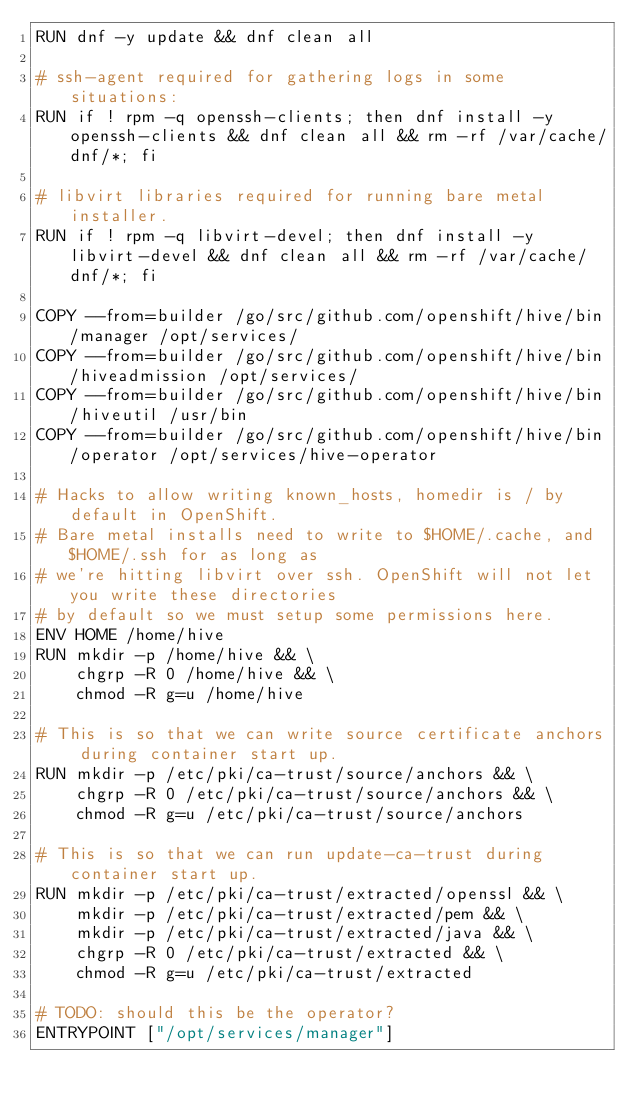Convert code to text. <code><loc_0><loc_0><loc_500><loc_500><_Dockerfile_>RUN dnf -y update && dnf clean all

# ssh-agent required for gathering logs in some situations:
RUN if ! rpm -q openssh-clients; then dnf install -y openssh-clients && dnf clean all && rm -rf /var/cache/dnf/*; fi

# libvirt libraries required for running bare metal installer.
RUN if ! rpm -q libvirt-devel; then dnf install -y libvirt-devel && dnf clean all && rm -rf /var/cache/dnf/*; fi

COPY --from=builder /go/src/github.com/openshift/hive/bin/manager /opt/services/
COPY --from=builder /go/src/github.com/openshift/hive/bin/hiveadmission /opt/services/
COPY --from=builder /go/src/github.com/openshift/hive/bin/hiveutil /usr/bin
COPY --from=builder /go/src/github.com/openshift/hive/bin/operator /opt/services/hive-operator

# Hacks to allow writing known_hosts, homedir is / by default in OpenShift.
# Bare metal installs need to write to $HOME/.cache, and $HOME/.ssh for as long as
# we're hitting libvirt over ssh. OpenShift will not let you write these directories
# by default so we must setup some permissions here.
ENV HOME /home/hive
RUN mkdir -p /home/hive && \
    chgrp -R 0 /home/hive && \
    chmod -R g=u /home/hive

# This is so that we can write source certificate anchors during container start up.
RUN mkdir -p /etc/pki/ca-trust/source/anchors && \
    chgrp -R 0 /etc/pki/ca-trust/source/anchors && \
    chmod -R g=u /etc/pki/ca-trust/source/anchors

# This is so that we can run update-ca-trust during container start up.
RUN mkdir -p /etc/pki/ca-trust/extracted/openssl && \
    mkdir -p /etc/pki/ca-trust/extracted/pem && \
    mkdir -p /etc/pki/ca-trust/extracted/java && \
    chgrp -R 0 /etc/pki/ca-trust/extracted && \
    chmod -R g=u /etc/pki/ca-trust/extracted

# TODO: should this be the operator?
ENTRYPOINT ["/opt/services/manager"]
</code> 